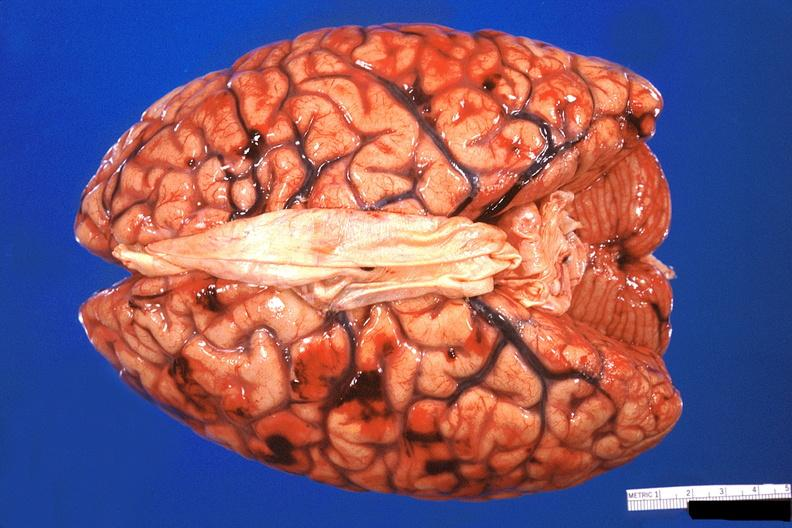what is present?
Answer the question using a single word or phrase. Nervous 